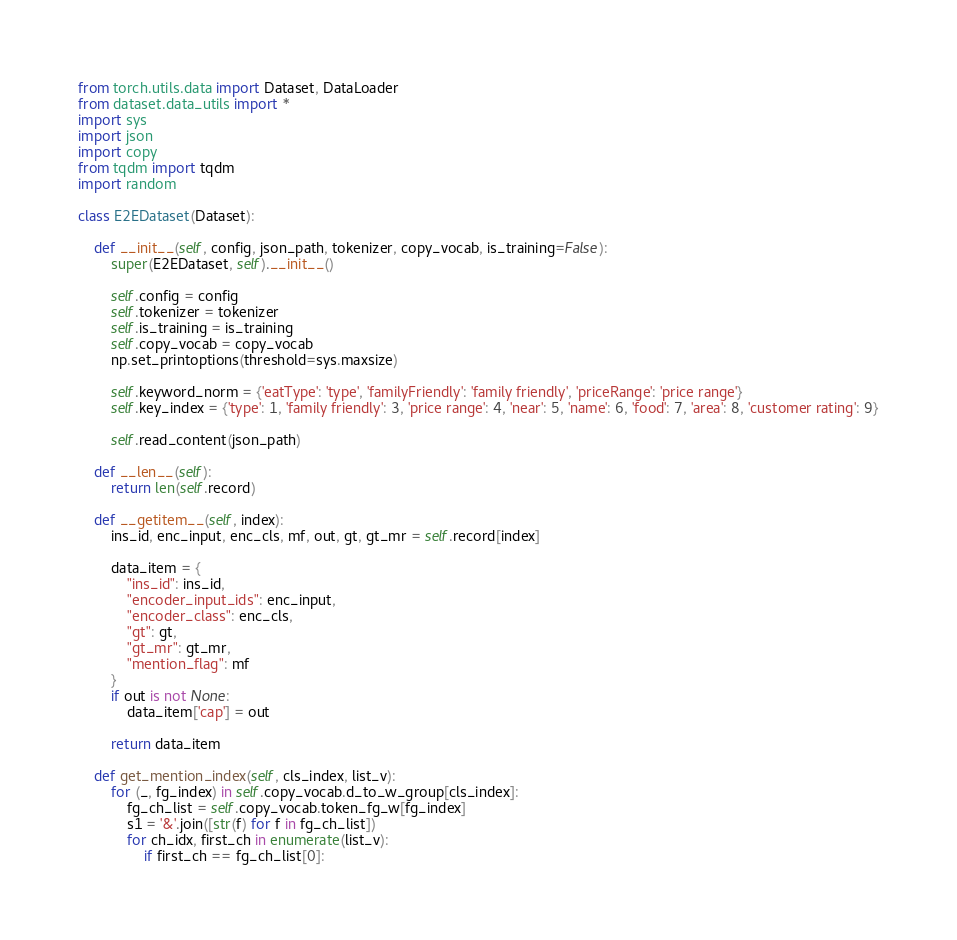<code> <loc_0><loc_0><loc_500><loc_500><_Python_>from torch.utils.data import Dataset, DataLoader
from dataset.data_utils import *
import sys
import json
import copy
from tqdm import tqdm
import random

class E2EDataset(Dataset):
	
	def __init__(self, config, json_path, tokenizer, copy_vocab, is_training=False):
		super(E2EDataset, self).__init__()

		self.config = config
		self.tokenizer = tokenizer
		self.is_training = is_training
		self.copy_vocab = copy_vocab
		np.set_printoptions(threshold=sys.maxsize)

		self.keyword_norm = {'eatType': 'type', 'familyFriendly': 'family friendly', 'priceRange': 'price range'}
		self.key_index = {'type': 1, 'family friendly': 3, 'price range': 4, 'near': 5, 'name': 6, 'food': 7, 'area': 8, 'customer rating': 9}

		self.read_content(json_path)

	def __len__(self):
		return len(self.record)

	def __getitem__(self, index):
		ins_id, enc_input, enc_cls, mf, out, gt, gt_mr = self.record[index]

		data_item = {
			"ins_id": ins_id,
			"encoder_input_ids": enc_input,
			"encoder_class": enc_cls,
			"gt": gt,
			"gt_mr": gt_mr,
			"mention_flag": mf
		}
		if out is not None:
			data_item['cap'] = out

		return data_item

	def get_mention_index(self, cls_index, list_v):
		for (_, fg_index) in self.copy_vocab.d_to_w_group[cls_index]:
			fg_ch_list = self.copy_vocab.token_fg_w[fg_index]
			s1 = '&'.join([str(f) for f in fg_ch_list])
			for ch_idx, first_ch in enumerate(list_v):
				if first_ch == fg_ch_list[0]:</code> 